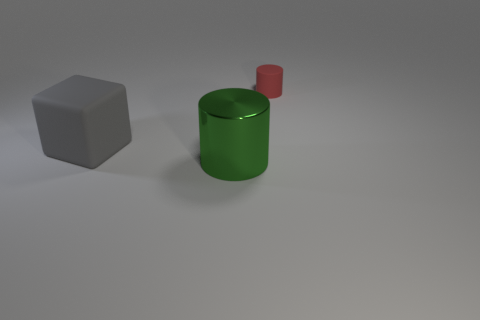Add 3 green cylinders. How many objects exist? 6 Subtract all blocks. How many objects are left? 2 Subtract all red cubes. Subtract all gray spheres. How many cubes are left? 1 Subtract all big brown metal cylinders. Subtract all small matte objects. How many objects are left? 2 Add 3 gray matte blocks. How many gray matte blocks are left? 4 Add 1 big rubber blocks. How many big rubber blocks exist? 2 Subtract 0 purple cylinders. How many objects are left? 3 